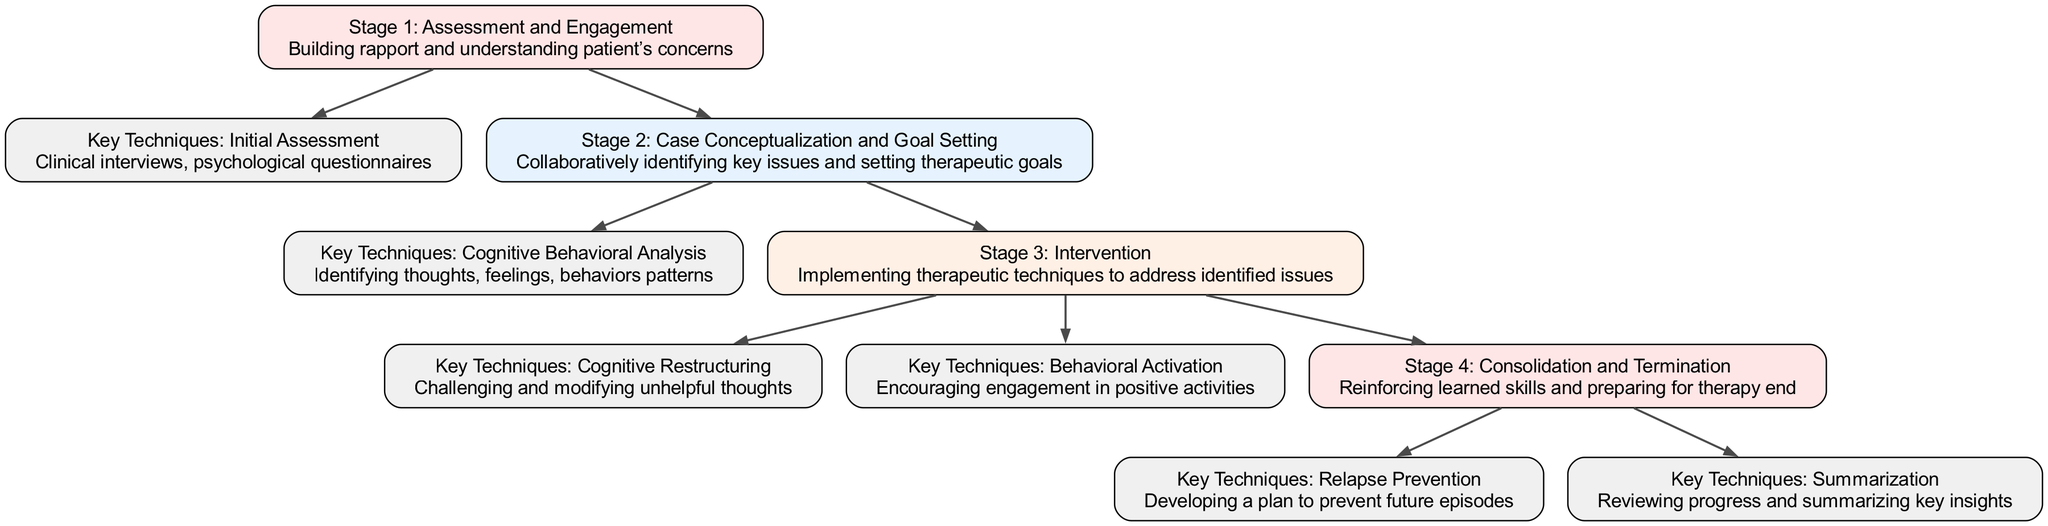What is the first stage of CBT described in the diagram? The diagram indicates that the first stage of CBT is labeled as "Stage 1: Assessment and Engagement." This can be found by looking at the nodes and identifying the first entry that represents a stage.
Answer: Stage 1: Assessment and Engagement How many stages are present in the diagram? By examining the nodes, there are four stages labeled: Stage 1, Stage 2, Stage 3, and Stage 4. The total count can be verified by counting these specific nodes in the diagram.
Answer: 4 What technique is associated with Stage 2? The technique associated with Stage 2 is "Cognitive Behavioral Analysis." This is determined by looking for the edges leading from Stage 2 to find the relevant technique node connected to it in the diagram.
Answer: Cognitive Behavioral Analysis Which stage involves "Reinforcing learned skills"? The stage that involves "Reinforcing learned skills" is labeled "Stage 4: Consolidation and Termination." This connection can be made by identifying the node that explicitly states this information.
Answer: Stage 4: Consolidation and Termination What is the primary focus of Key Techniques in Stage 3? The primary focus of Key Techniques in Stage 3 includes "Cognitive Restructuring" and "Behavioral Activation." This can be deduced by looking at the techniques linked to the Stage 3 node in the diagram, highlighting the specific aims of the intervention stage.
Answer: Cognitive Restructuring and Behavioral Activation How many key techniques are mentioned in the whole diagram? The diagram outlines six key techniques: Initial Assessment, Cognitive Behavioral Analysis, Cognitive Restructuring, Behavioral Activation, Relapse Prevention, and Summarization. The total count is derived from identifying all the relevant technique nodes present in the diagram.
Answer: 6 What relationship exists between Stage 1 and Stage 3? The relationship between Stage 1 and Stage 3 is that Stage 1 leads to Stage 3 through the progression of therapy—initial assessment leads into case conceptualization and goal setting before reaching intervention. This can be understood by analyzing the edges connecting the respective stages.
Answer: Leads to Which technique comes before "Relapse Prevention"? "Summarization" is the technique that comes before "Relapse Prevention." This can be determined by following the connections from Stage 4, which contains both techniques and understanding their order as per the edges drawn in the diagram.
Answer: Summarization What is the purpose of "Behavioral Activation"? The purpose of "Behavioral Activation" is to encourage engagement in positive activities. This is identified from the details provided within the relevant technique node in the diagram.
Answer: Encouraging engagement in positive activities 